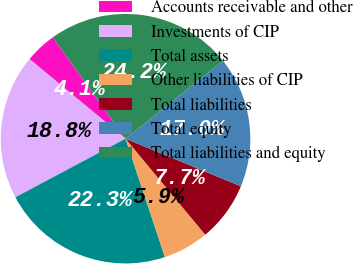<chart> <loc_0><loc_0><loc_500><loc_500><pie_chart><fcel>Accounts receivable and other<fcel>Investments of CIP<fcel>Total assets<fcel>Other liabilities of CIP<fcel>Total liabilities<fcel>Total equity<fcel>Total liabilities and equity<nl><fcel>4.09%<fcel>18.79%<fcel>22.33%<fcel>5.92%<fcel>7.74%<fcel>16.97%<fcel>24.16%<nl></chart> 